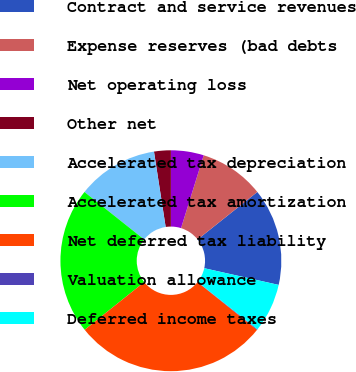<chart> <loc_0><loc_0><loc_500><loc_500><pie_chart><fcel>Contract and service revenues<fcel>Expense reserves (bad debts<fcel>Net operating loss<fcel>Other net<fcel>Accelerated tax depreciation<fcel>Accelerated tax amortization<fcel>Net deferred tax liability<fcel>Valuation allowance<fcel>Deferred income taxes<nl><fcel>14.21%<fcel>9.5%<fcel>4.8%<fcel>2.45%<fcel>11.86%<fcel>21.44%<fcel>28.49%<fcel>0.1%<fcel>7.15%<nl></chart> 